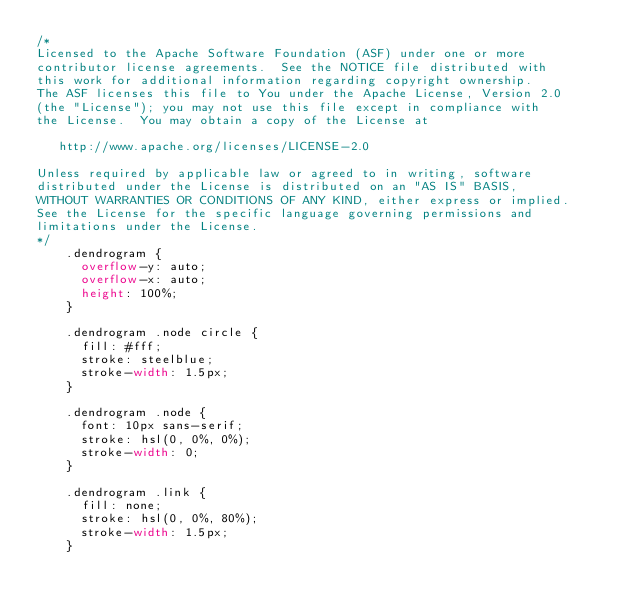Convert code to text. <code><loc_0><loc_0><loc_500><loc_500><_CSS_>/*
Licensed to the Apache Software Foundation (ASF) under one or more
contributor license agreements.  See the NOTICE file distributed with
this work for additional information regarding copyright ownership.
The ASF licenses this file to You under the Apache License, Version 2.0
(the "License"); you may not use this file except in compliance with
the License.  You may obtain a copy of the License at

   http://www.apache.org/licenses/LICENSE-2.0

Unless required by applicable law or agreed to in writing, software
distributed under the License is distributed on an "AS IS" BASIS,
WITHOUT WARRANTIES OR CONDITIONS OF ANY KIND, either express or implied.
See the License for the specific language governing permissions and
limitations under the License.
*/
    .dendrogram {
      overflow-y: auto;
      overflow-x: auto;
      height: 100%;
    }

    .dendrogram .node circle {
      fill: #fff;
      stroke: steelblue;
      stroke-width: 1.5px;
    }

    .dendrogram .node {
      font: 10px sans-serif;
      stroke: hsl(0, 0%, 0%);
      stroke-width: 0;
    }

    .dendrogram .link {
      fill: none;
      stroke: hsl(0, 0%, 80%);
      stroke-width: 1.5px;
    }
</code> 